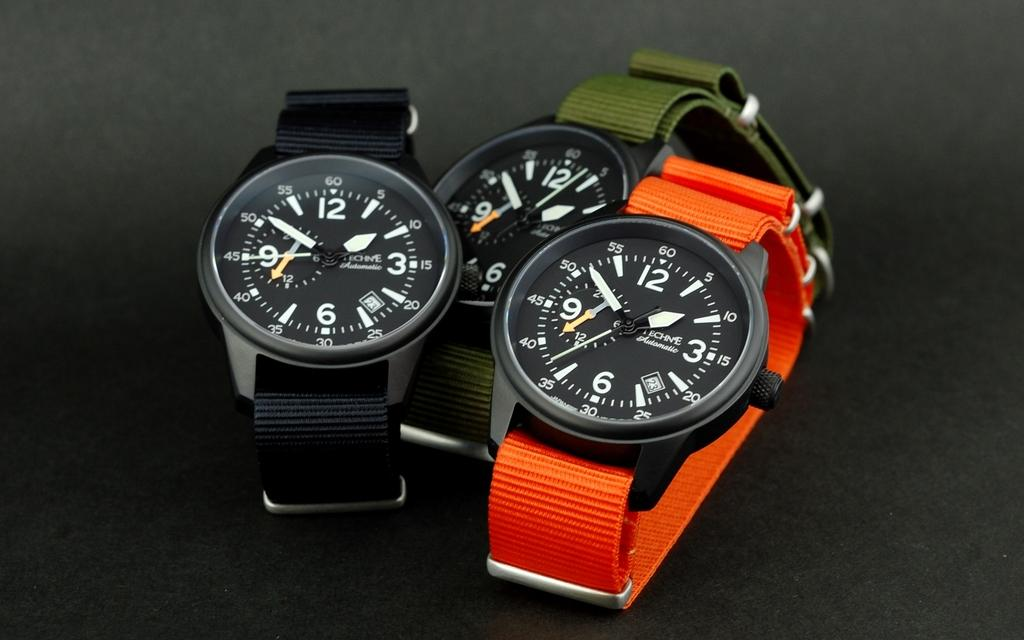<image>
Write a terse but informative summary of the picture. Three watches side by side with one saying ECHNE on it. 